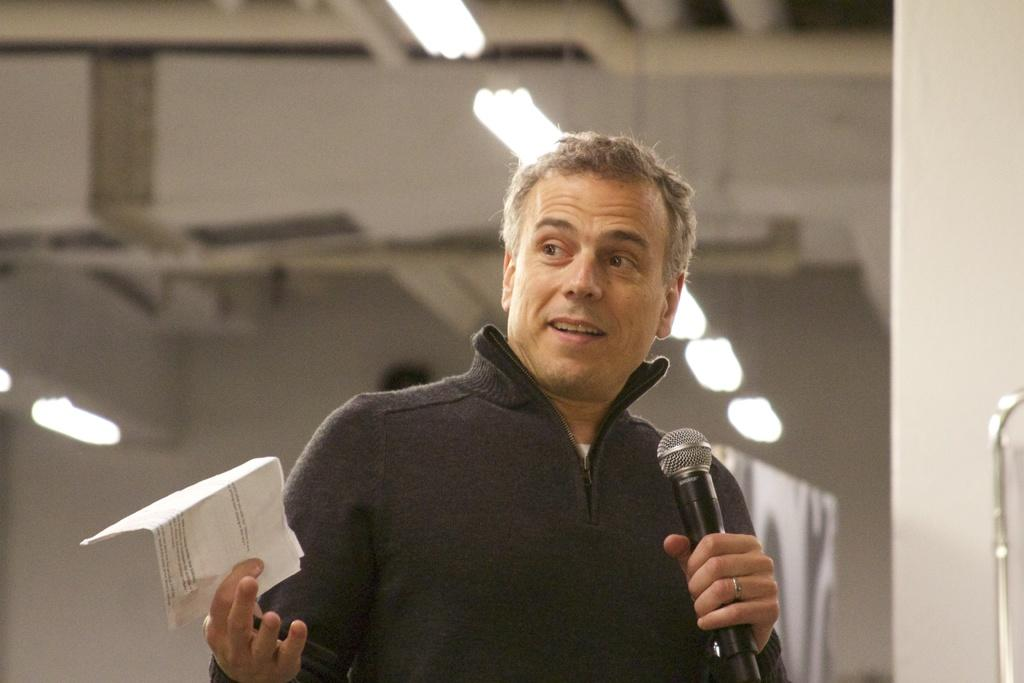Who is present in the image? There is a man in the image. What is the man doing in the image? The man is standing in the image. What objects is the man holding in the image? The man is holding a microphone in one hand and a paper in the other hand. What can be seen on the roof in the image? There are lights on the roof in the image. What type of eggnog is the man drinking in the image? There is no eggnog present in the image; the man is holding a microphone and a paper. 